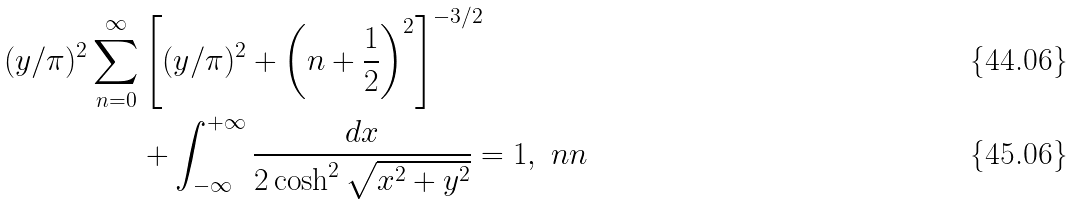Convert formula to latex. <formula><loc_0><loc_0><loc_500><loc_500>( y / \pi ) ^ { 2 } \sum _ { n = 0 } ^ { \infty } & \left [ ( y / \pi ) ^ { 2 } + \left ( n + \frac { 1 } { 2 } \right ) ^ { 2 } \right ] ^ { - 3 / 2 } \\ & + \int _ { - \infty } ^ { + \infty } \frac { d x } { 2 \cosh ^ { 2 } \sqrt { x ^ { 2 } + y ^ { 2 } } } = 1 , \ n n</formula> 